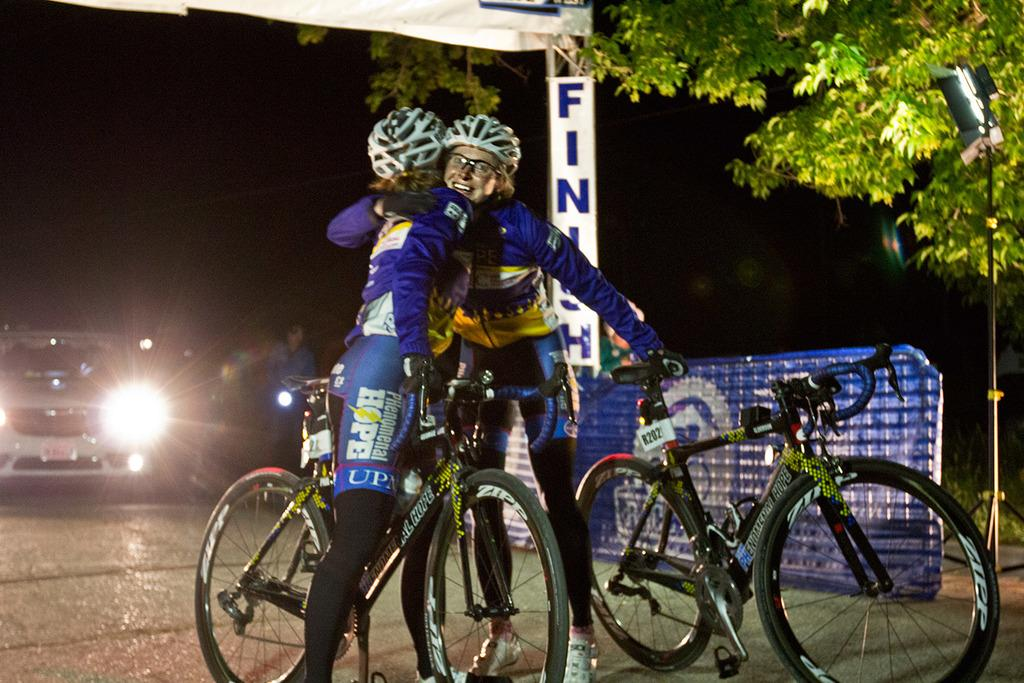How many persons are present in the image? There are two persons standing in the image. What mode of transportation can be seen in the image? There are bicycles in the image. What other type of vehicle is present in the image? There is a car in the image. What type of plant is visible in the image? There is a tree in the image. What type of yarn is being used to create a camp in the image? There is no camp or yarn present in the image. How many stamps are visible on the car in the image? There are no stamps visible on the car in the image. 